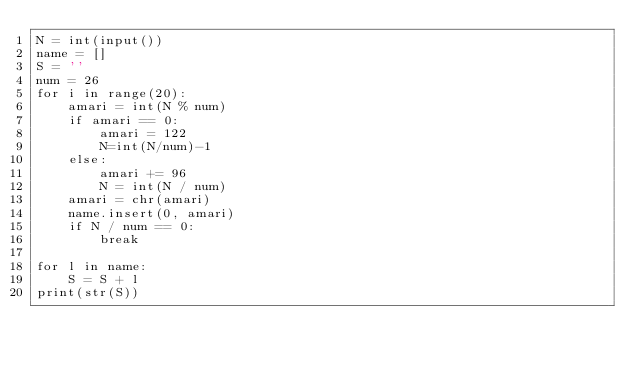<code> <loc_0><loc_0><loc_500><loc_500><_Python_>N = int(input())
name = []
S = ''
num = 26
for i in range(20):
    amari = int(N % num)
    if amari == 0:
        amari = 122
        N=int(N/num)-1
    else:
        amari += 96
        N = int(N / num)
    amari = chr(amari)    
    name.insert(0, amari)
    if N / num == 0:
        break

for l in name:
    S = S + l
print(str(S))</code> 